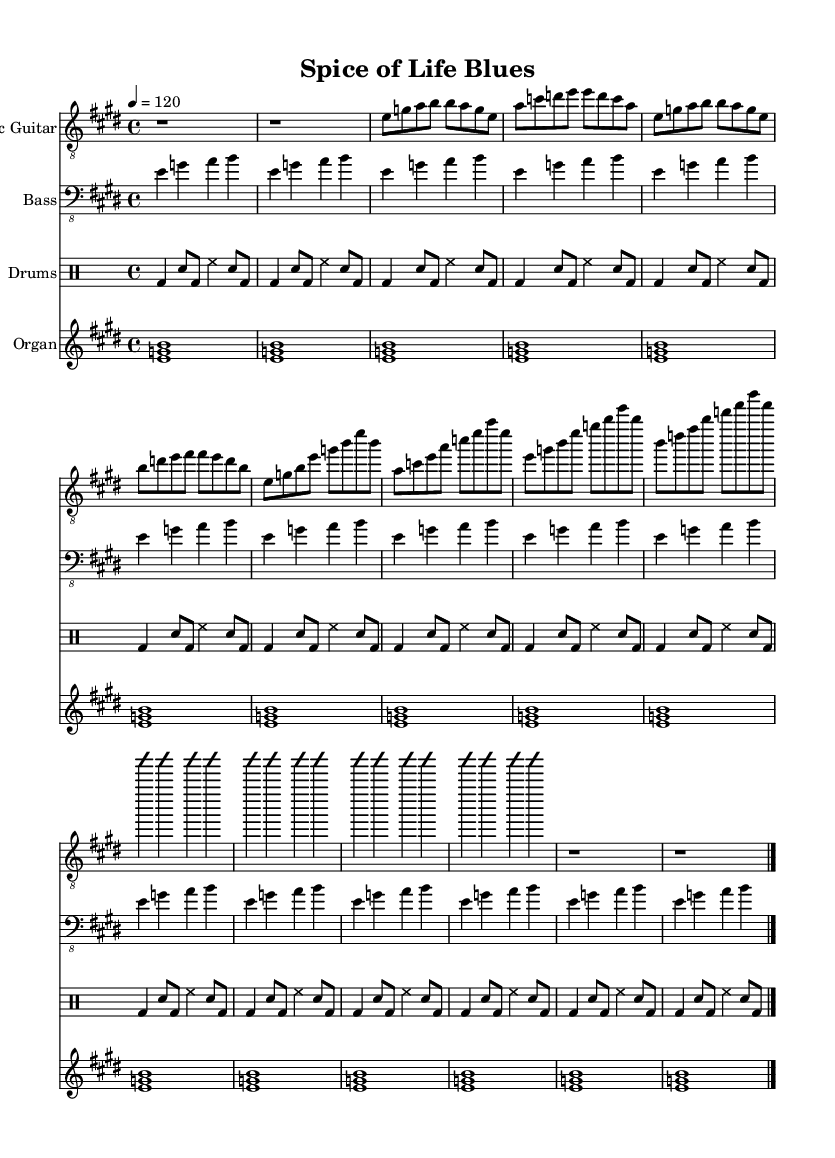What is the key signature of this music? The key signature is E major, indicated by four sharps. In the music sheet, the sharp symbols are present at the beginning of the staff, specifying the key.
Answer: E major What is the time signature of this piece? The time signature is 4/4, which indicates that there are four beats per measure and a quarter note gets one beat. This is shown at the beginning of the score after the key signature.
Answer: 4/4 What is the tempo marking for this music? The tempo marking is 120 beats per minute, noted at the start of the piece with a "4 = 120" indication, which means each quarter note is played at that speed.
Answer: 120 How many measures are in the introductory section? The introductory section consists of 2 measures, as indicated by the rhythmic notation and rests present at the beginning of the piece.
Answer: 2 What style of music does this piece represent? The style of this music is Electric Blues, characterized by an upbeat tempo, use of electric guitar, and expression of emotional themes through improvisation and phrasing. This is inherent in the structural elements of the score.
Answer: Electric Blues What instrument plays the simplified walking bass line? The electric bass guitar plays the simplified walking bass line, as indicated by the clef designation and musical notation associated with that particular staff.
Answer: Bass What is the primary theme reflected in the song title "Spice of Life Blues"? The primary theme reflected in the song title relates to the immigrant experience and culinary traditions, emphasized by the blues genre's emotional storytelling and use of spices as a metaphor for diverse cultural flavors.
Answer: Immigrant experience 